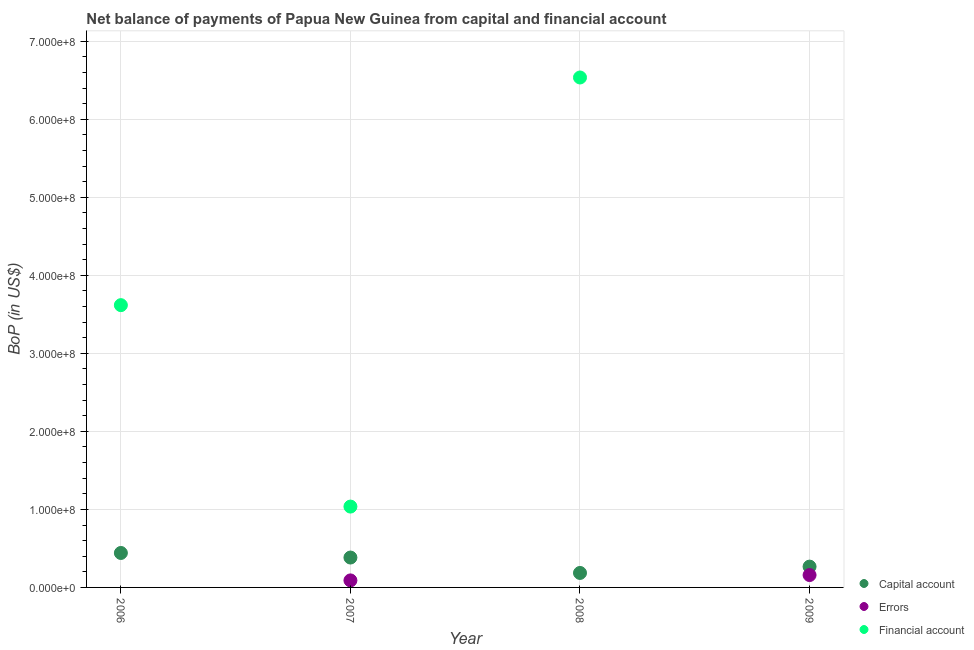What is the amount of financial account in 2007?
Offer a terse response. 1.04e+08. Across all years, what is the maximum amount of errors?
Offer a very short reply. 1.59e+07. Across all years, what is the minimum amount of net capital account?
Offer a very short reply. 1.86e+07. What is the total amount of net capital account in the graph?
Your response must be concise. 1.28e+08. What is the difference between the amount of errors in 2007 and that in 2009?
Provide a short and direct response. -6.86e+06. What is the difference between the amount of net capital account in 2006 and the amount of errors in 2008?
Offer a very short reply. 4.42e+07. What is the average amount of net capital account per year?
Keep it short and to the point. 3.19e+07. In the year 2007, what is the difference between the amount of net capital account and amount of errors?
Ensure brevity in your answer.  2.93e+07. In how many years, is the amount of financial account greater than 600000000 US$?
Ensure brevity in your answer.  1. What is the ratio of the amount of net capital account in 2007 to that in 2008?
Offer a terse response. 2.06. What is the difference between the highest and the second highest amount of net capital account?
Your answer should be very brief. 5.86e+06. What is the difference between the highest and the lowest amount of errors?
Give a very brief answer. 1.59e+07. In how many years, is the amount of net capital account greater than the average amount of net capital account taken over all years?
Your answer should be very brief. 2. Is the amount of net capital account strictly greater than the amount of financial account over the years?
Offer a terse response. No. How many years are there in the graph?
Your answer should be compact. 4. What is the difference between two consecutive major ticks on the Y-axis?
Ensure brevity in your answer.  1.00e+08. Does the graph contain grids?
Make the answer very short. Yes. What is the title of the graph?
Offer a very short reply. Net balance of payments of Papua New Guinea from capital and financial account. Does "Ages 15-20" appear as one of the legend labels in the graph?
Your response must be concise. No. What is the label or title of the Y-axis?
Provide a succinct answer. BoP (in US$). What is the BoP (in US$) of Capital account in 2006?
Offer a very short reply. 4.42e+07. What is the BoP (in US$) in Financial account in 2006?
Provide a short and direct response. 3.62e+08. What is the BoP (in US$) in Capital account in 2007?
Make the answer very short. 3.83e+07. What is the BoP (in US$) in Errors in 2007?
Give a very brief answer. 9.00e+06. What is the BoP (in US$) of Financial account in 2007?
Give a very brief answer. 1.04e+08. What is the BoP (in US$) in Capital account in 2008?
Your answer should be compact. 1.86e+07. What is the BoP (in US$) of Errors in 2008?
Offer a terse response. 0. What is the BoP (in US$) in Financial account in 2008?
Provide a succinct answer. 6.54e+08. What is the BoP (in US$) in Capital account in 2009?
Make the answer very short. 2.67e+07. What is the BoP (in US$) in Errors in 2009?
Ensure brevity in your answer.  1.59e+07. What is the BoP (in US$) of Financial account in 2009?
Offer a very short reply. 0. Across all years, what is the maximum BoP (in US$) in Capital account?
Make the answer very short. 4.42e+07. Across all years, what is the maximum BoP (in US$) of Errors?
Your response must be concise. 1.59e+07. Across all years, what is the maximum BoP (in US$) of Financial account?
Give a very brief answer. 6.54e+08. Across all years, what is the minimum BoP (in US$) of Capital account?
Your response must be concise. 1.86e+07. What is the total BoP (in US$) in Capital account in the graph?
Give a very brief answer. 1.28e+08. What is the total BoP (in US$) in Errors in the graph?
Provide a succinct answer. 2.49e+07. What is the total BoP (in US$) in Financial account in the graph?
Offer a very short reply. 1.12e+09. What is the difference between the BoP (in US$) in Capital account in 2006 and that in 2007?
Make the answer very short. 5.86e+06. What is the difference between the BoP (in US$) of Financial account in 2006 and that in 2007?
Keep it short and to the point. 2.58e+08. What is the difference between the BoP (in US$) of Capital account in 2006 and that in 2008?
Give a very brief answer. 2.56e+07. What is the difference between the BoP (in US$) of Financial account in 2006 and that in 2008?
Make the answer very short. -2.92e+08. What is the difference between the BoP (in US$) of Capital account in 2006 and that in 2009?
Your response must be concise. 1.75e+07. What is the difference between the BoP (in US$) in Capital account in 2007 and that in 2008?
Give a very brief answer. 1.98e+07. What is the difference between the BoP (in US$) of Financial account in 2007 and that in 2008?
Provide a short and direct response. -5.50e+08. What is the difference between the BoP (in US$) in Capital account in 2007 and that in 2009?
Keep it short and to the point. 1.16e+07. What is the difference between the BoP (in US$) in Errors in 2007 and that in 2009?
Your answer should be compact. -6.86e+06. What is the difference between the BoP (in US$) in Capital account in 2008 and that in 2009?
Make the answer very short. -8.12e+06. What is the difference between the BoP (in US$) in Capital account in 2006 and the BoP (in US$) in Errors in 2007?
Give a very brief answer. 3.52e+07. What is the difference between the BoP (in US$) of Capital account in 2006 and the BoP (in US$) of Financial account in 2007?
Keep it short and to the point. -5.95e+07. What is the difference between the BoP (in US$) of Capital account in 2006 and the BoP (in US$) of Financial account in 2008?
Offer a terse response. -6.09e+08. What is the difference between the BoP (in US$) of Capital account in 2006 and the BoP (in US$) of Errors in 2009?
Ensure brevity in your answer.  2.83e+07. What is the difference between the BoP (in US$) in Capital account in 2007 and the BoP (in US$) in Financial account in 2008?
Keep it short and to the point. -6.15e+08. What is the difference between the BoP (in US$) of Errors in 2007 and the BoP (in US$) of Financial account in 2008?
Give a very brief answer. -6.45e+08. What is the difference between the BoP (in US$) of Capital account in 2007 and the BoP (in US$) of Errors in 2009?
Offer a terse response. 2.24e+07. What is the difference between the BoP (in US$) in Capital account in 2008 and the BoP (in US$) in Errors in 2009?
Offer a very short reply. 2.69e+06. What is the average BoP (in US$) in Capital account per year?
Provide a succinct answer. 3.19e+07. What is the average BoP (in US$) in Errors per year?
Your answer should be compact. 6.22e+06. What is the average BoP (in US$) in Financial account per year?
Ensure brevity in your answer.  2.80e+08. In the year 2006, what is the difference between the BoP (in US$) of Capital account and BoP (in US$) of Financial account?
Keep it short and to the point. -3.18e+08. In the year 2007, what is the difference between the BoP (in US$) of Capital account and BoP (in US$) of Errors?
Provide a short and direct response. 2.93e+07. In the year 2007, what is the difference between the BoP (in US$) of Capital account and BoP (in US$) of Financial account?
Your answer should be very brief. -6.53e+07. In the year 2007, what is the difference between the BoP (in US$) of Errors and BoP (in US$) of Financial account?
Provide a short and direct response. -9.46e+07. In the year 2008, what is the difference between the BoP (in US$) of Capital account and BoP (in US$) of Financial account?
Your answer should be very brief. -6.35e+08. In the year 2009, what is the difference between the BoP (in US$) of Capital account and BoP (in US$) of Errors?
Give a very brief answer. 1.08e+07. What is the ratio of the BoP (in US$) in Capital account in 2006 to that in 2007?
Your response must be concise. 1.15. What is the ratio of the BoP (in US$) of Financial account in 2006 to that in 2007?
Provide a succinct answer. 3.49. What is the ratio of the BoP (in US$) in Capital account in 2006 to that in 2008?
Make the answer very short. 2.38. What is the ratio of the BoP (in US$) of Financial account in 2006 to that in 2008?
Give a very brief answer. 0.55. What is the ratio of the BoP (in US$) in Capital account in 2006 to that in 2009?
Make the answer very short. 1.66. What is the ratio of the BoP (in US$) in Capital account in 2007 to that in 2008?
Keep it short and to the point. 2.06. What is the ratio of the BoP (in US$) of Financial account in 2007 to that in 2008?
Provide a succinct answer. 0.16. What is the ratio of the BoP (in US$) of Capital account in 2007 to that in 2009?
Your response must be concise. 1.44. What is the ratio of the BoP (in US$) of Errors in 2007 to that in 2009?
Your response must be concise. 0.57. What is the ratio of the BoP (in US$) of Capital account in 2008 to that in 2009?
Your answer should be very brief. 0.7. What is the difference between the highest and the second highest BoP (in US$) of Capital account?
Provide a succinct answer. 5.86e+06. What is the difference between the highest and the second highest BoP (in US$) of Financial account?
Your answer should be very brief. 2.92e+08. What is the difference between the highest and the lowest BoP (in US$) of Capital account?
Provide a succinct answer. 2.56e+07. What is the difference between the highest and the lowest BoP (in US$) in Errors?
Offer a terse response. 1.59e+07. What is the difference between the highest and the lowest BoP (in US$) of Financial account?
Make the answer very short. 6.54e+08. 